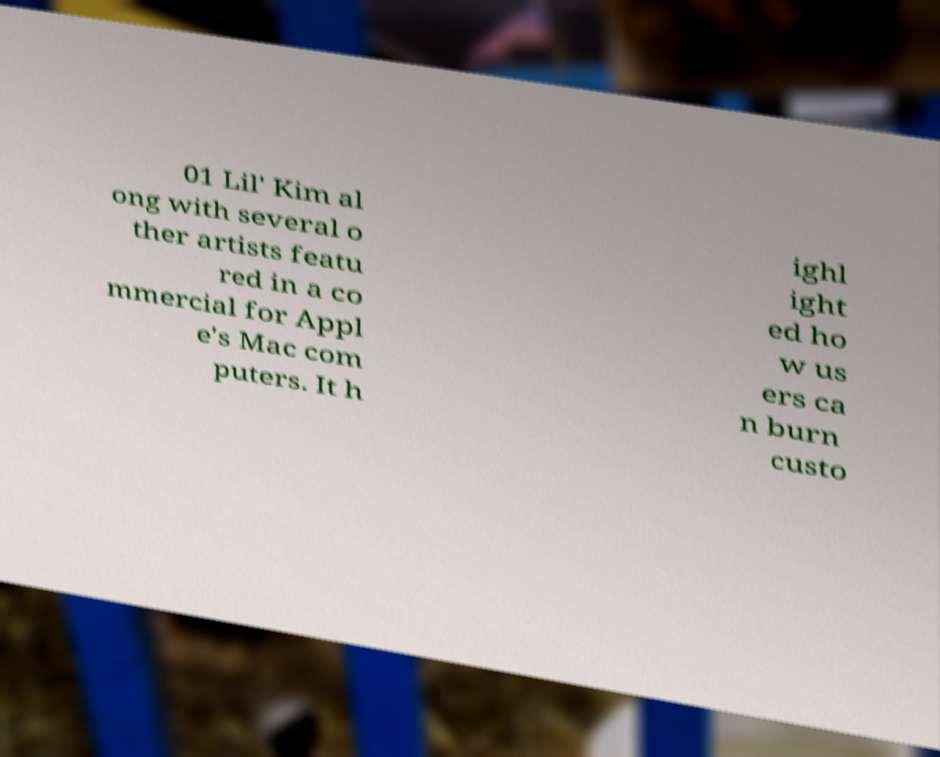What messages or text are displayed in this image? I need them in a readable, typed format. 01 Lil' Kim al ong with several o ther artists featu red in a co mmercial for Appl e's Mac com puters. It h ighl ight ed ho w us ers ca n burn custo 